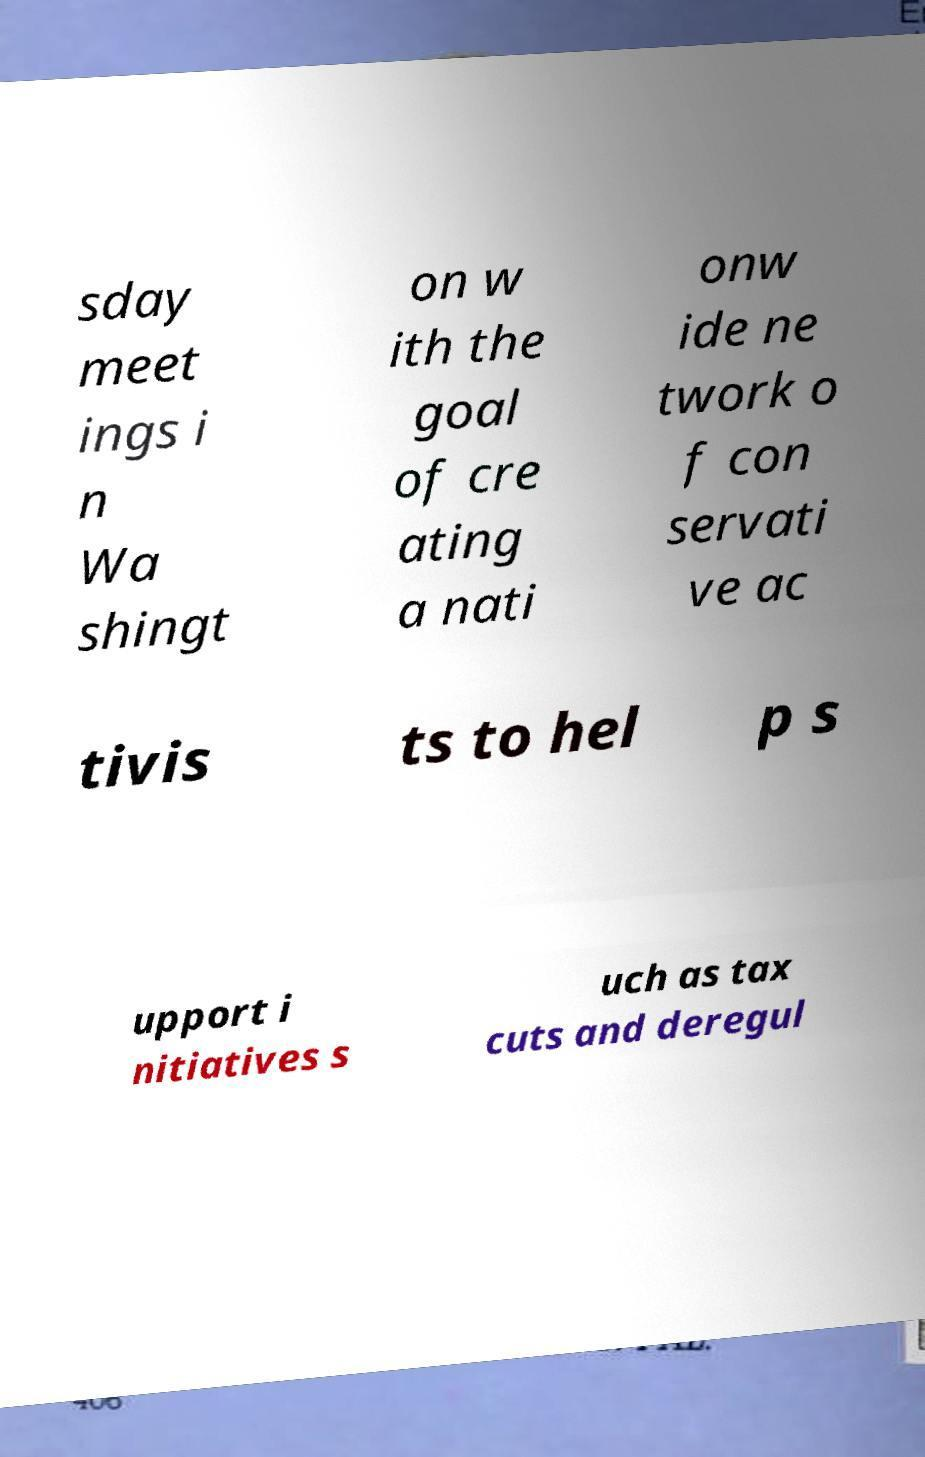Please read and relay the text visible in this image. What does it say? sday meet ings i n Wa shingt on w ith the goal of cre ating a nati onw ide ne twork o f con servati ve ac tivis ts to hel p s upport i nitiatives s uch as tax cuts and deregul 